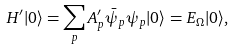<formula> <loc_0><loc_0><loc_500><loc_500>H ^ { \prime } | 0 \rangle = \sum _ { p } A ^ { \prime } _ { p } \bar { \psi } _ { p } \psi _ { p } | 0 \rangle = E _ { \Omega } | 0 \rangle ,</formula> 